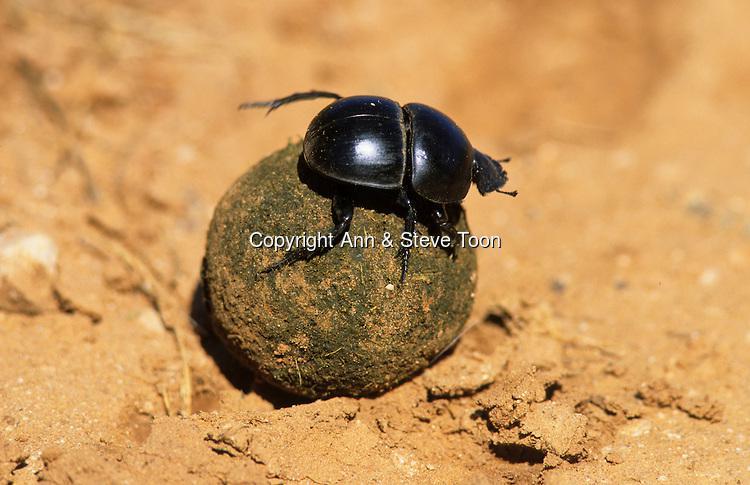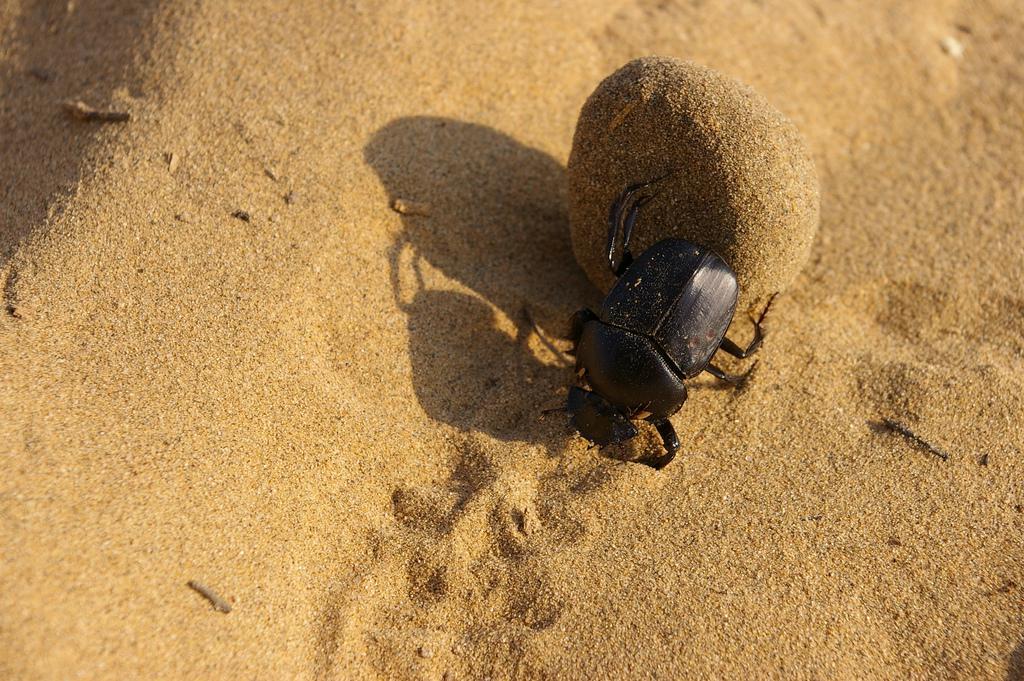The first image is the image on the left, the second image is the image on the right. Assess this claim about the two images: "There are two bugs in one of the images.". Correct or not? Answer yes or no. No. 